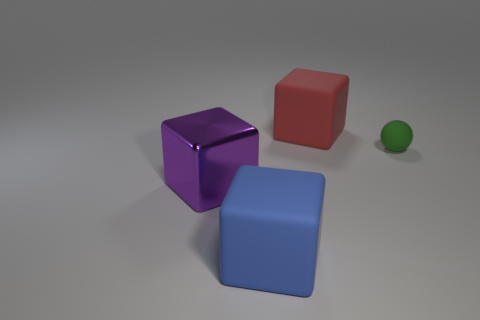What's the general mood or atmosphere this image evokes, based on the lighting and the arrangement of objects? The mood of the image is calm and neutral, with soft and uniform lighting that doesn't cast strong shadows. The simple arrangement of geometric shapes in a clean space gives it a minimalist and serene feel. 